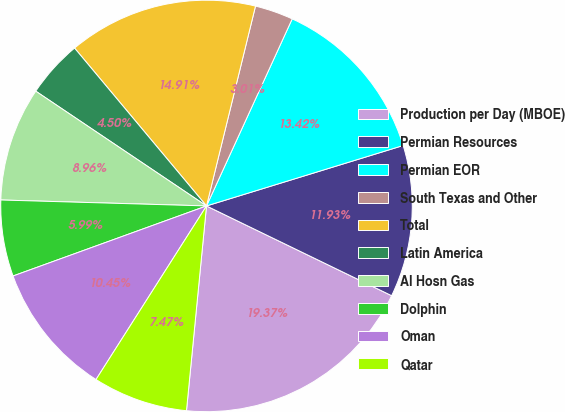Convert chart. <chart><loc_0><loc_0><loc_500><loc_500><pie_chart><fcel>Production per Day (MBOE)<fcel>Permian Resources<fcel>Permian EOR<fcel>South Texas and Other<fcel>Total<fcel>Latin America<fcel>Al Hosn Gas<fcel>Dolphin<fcel>Oman<fcel>Qatar<nl><fcel>19.37%<fcel>11.93%<fcel>13.42%<fcel>3.01%<fcel>14.91%<fcel>4.5%<fcel>8.96%<fcel>5.99%<fcel>10.45%<fcel>7.47%<nl></chart> 